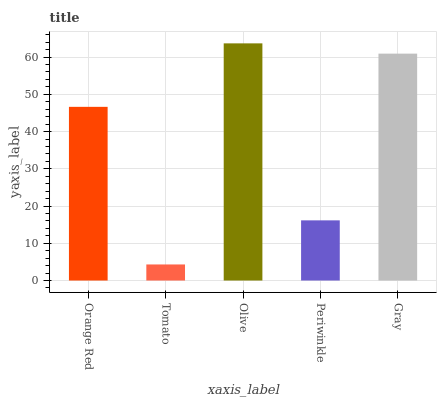Is Tomato the minimum?
Answer yes or no. Yes. Is Olive the maximum?
Answer yes or no. Yes. Is Olive the minimum?
Answer yes or no. No. Is Tomato the maximum?
Answer yes or no. No. Is Olive greater than Tomato?
Answer yes or no. Yes. Is Tomato less than Olive?
Answer yes or no. Yes. Is Tomato greater than Olive?
Answer yes or no. No. Is Olive less than Tomato?
Answer yes or no. No. Is Orange Red the high median?
Answer yes or no. Yes. Is Orange Red the low median?
Answer yes or no. Yes. Is Olive the high median?
Answer yes or no. No. Is Periwinkle the low median?
Answer yes or no. No. 